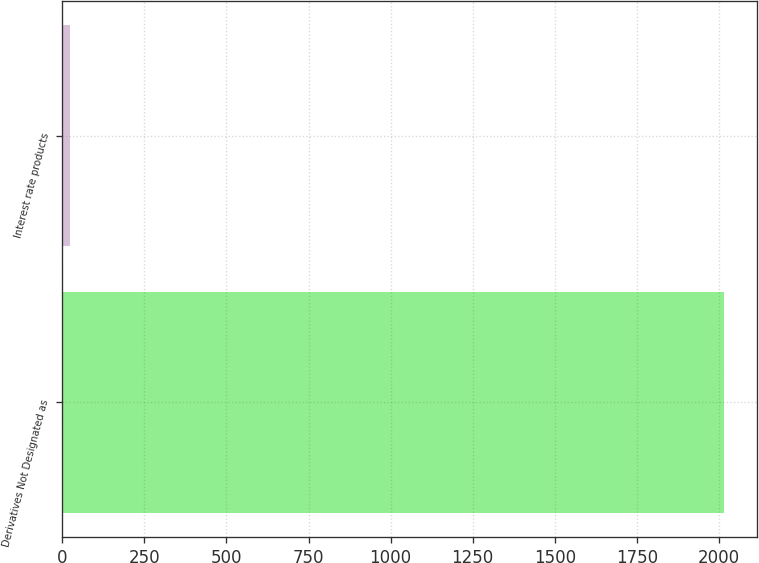Convert chart to OTSL. <chart><loc_0><loc_0><loc_500><loc_500><bar_chart><fcel>Derivatives Not Designated as<fcel>Interest rate products<nl><fcel>2015<fcel>23<nl></chart> 